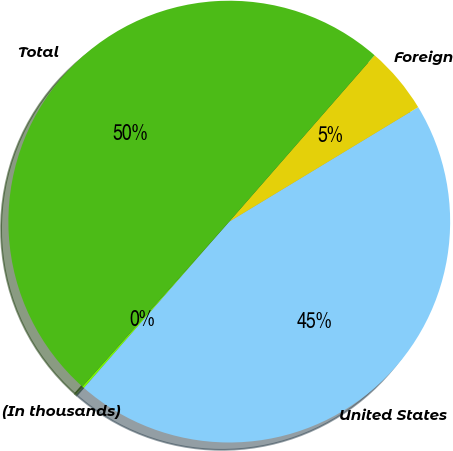Convert chart. <chart><loc_0><loc_0><loc_500><loc_500><pie_chart><fcel>(In thousands)<fcel>United States<fcel>Foreign<fcel>Total<nl><fcel>0.15%<fcel>45.1%<fcel>4.9%<fcel>49.85%<nl></chart> 